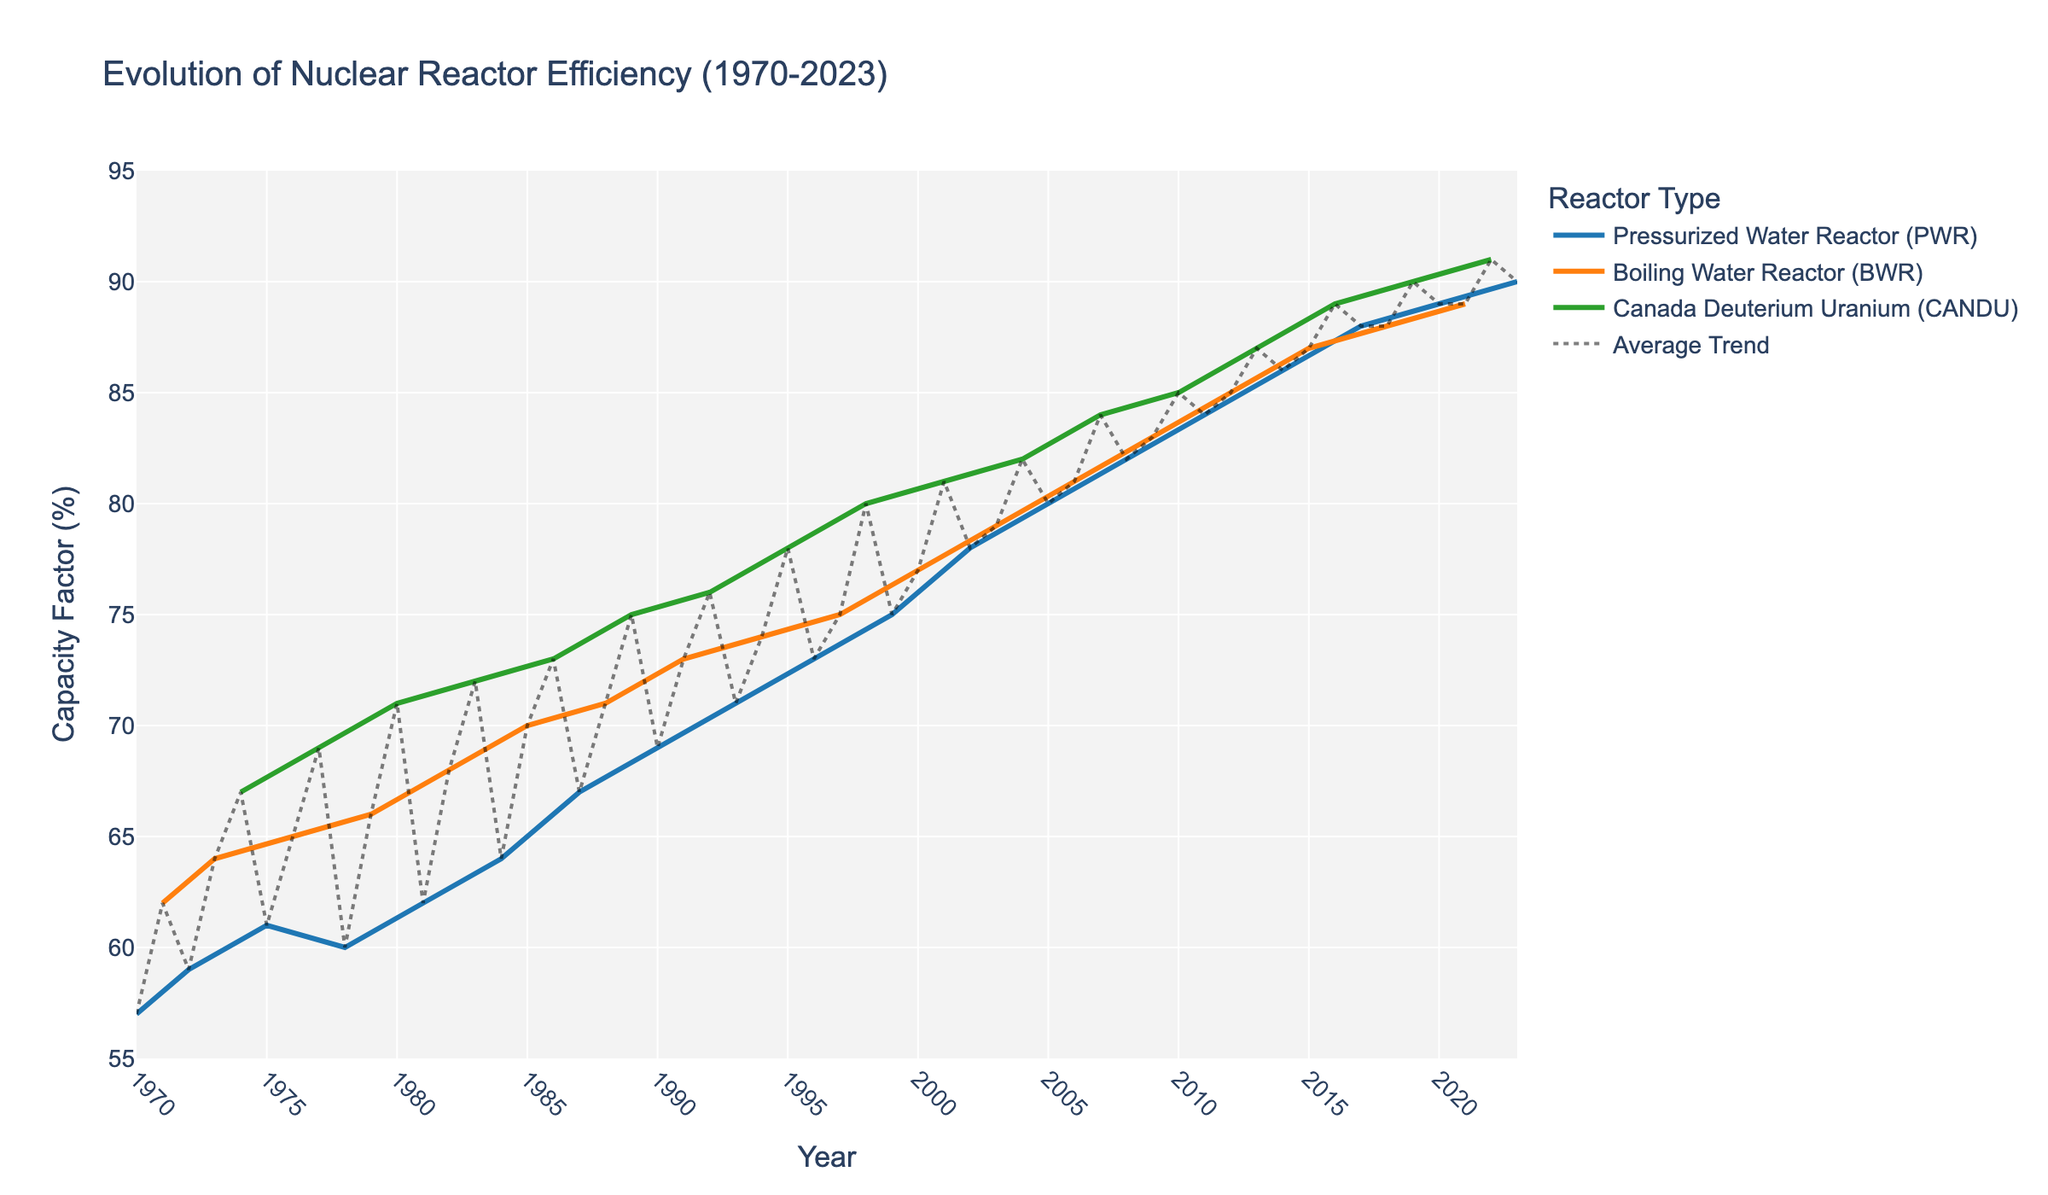What's the title of the plot? The title of the plot is written at the top, showing the overall subject of the figure. The title is "Evolution of Nuclear Reactor Efficiency (1970-2023)."
Answer: Evolution of Nuclear Reactor Efficiency (1970-2023) What is the y-axis range in the plot? The y-axis represents the Capacity Factor (%) and has a range specified from 55 to 95. This range is set to include all data points within these limits.
Answer: 55 to 95 How often are the x-axis ticks labeled? The x-axis, representing years, has labeled ticks every 5 years. This helps to provide a clear and evenly spaced time scale.
Answer: Every 5 years Which reactor type shows the highest capacity factor in 1980? By examining the plotted data points for the year 1980, the reactor with the highest capacity factor is the Canada Deuterium Uranium (CANDU) reactor. It has a capacity factor of 71%.
Answer: Canada Deuterium Uranium (CANDU) Between which years did the Pressurized Water Reactor (PWR) surpass the 80% capacity factor? By following the Pressurized Water Reactor (PWR) line, it first surpassed the 80% capacity factor from around the year 2005 and continued to maintain values above 80% beyond that period.
Answer: From 2005 onwards What is the trend of the average capacity factor over time? The trend line added to the plot shows the overall trend of the average capacity factor. From the plot, the average trend increases steadily from 1970 to 2023.
Answer: Increasing How does the capacity factor of the Boiling Water Reactor (BWR) in 1971 compare to its value in 2021? The capacity factor of the Boiling Water Reactor (BWR) in 1971 was 62%, while in 2021, it was 89%. This shows a significant increase over these years.
Answer: Increased What can you infer about the performance improvement of CANDU reactors compared to PWR and BWR reactors from 1970 to 2023? By examining the trends of the three reactor types, CANDU reactors consistently show a higher capacity factor compared to PWR and BWR reactors. Since 1974, it has maintained the highest values, indicating more efficient performance improvements overall.
Answer: CANDU reactors show the most improvement Which year has the most similar capacity factors for all reactor types? By closely examining the lines for all three reactor types, the year 2022 shows very similar capacity factors, with PWR at 90%, BWR at 89%, and CANDU at 91%.
Answer: 2022 